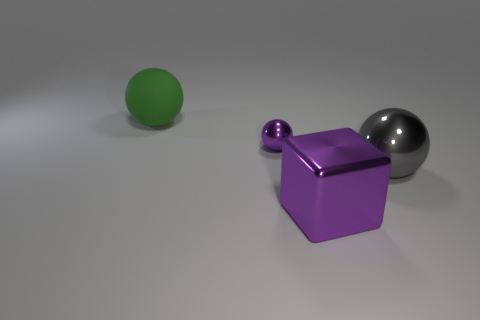Add 3 big purple cubes. How many objects exist? 7 Subtract all cubes. How many objects are left? 3 Add 1 small green cubes. How many small green cubes exist? 1 Subtract 0 blue cylinders. How many objects are left? 4 Subtract all tiny yellow matte things. Subtract all cubes. How many objects are left? 3 Add 2 tiny purple objects. How many tiny purple objects are left? 3 